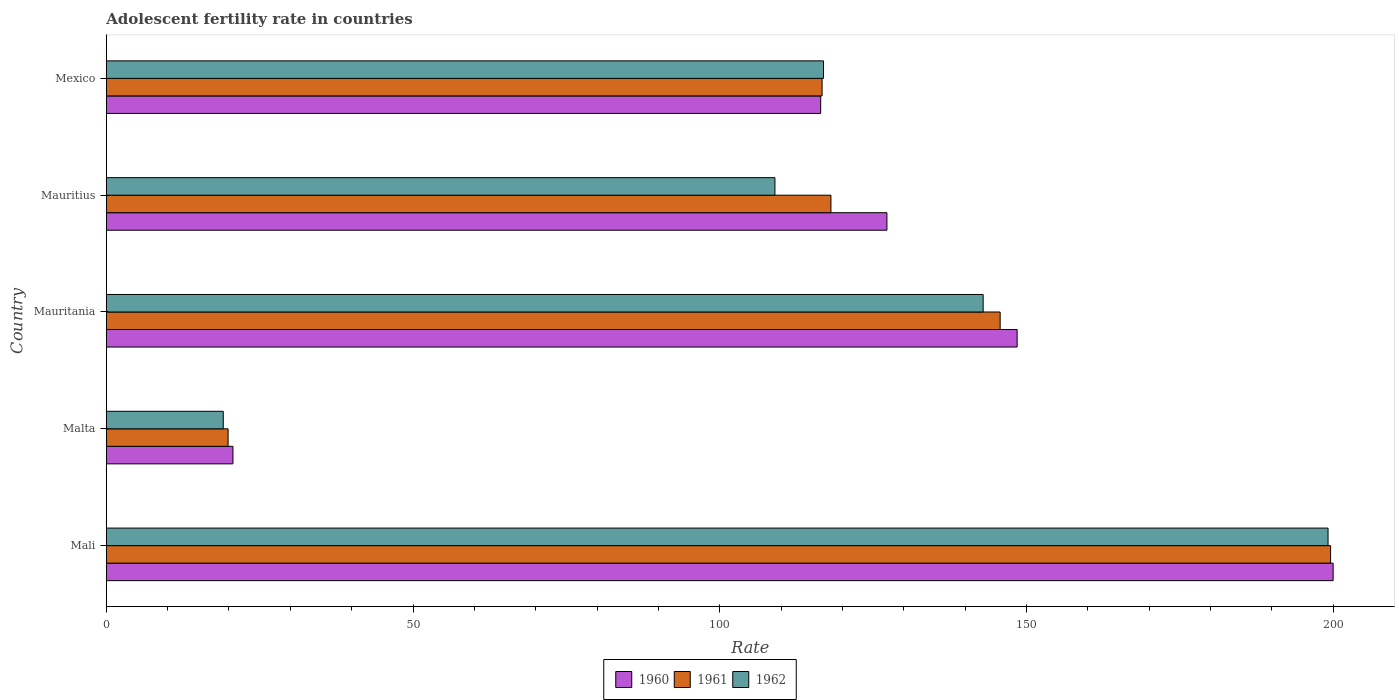How many different coloured bars are there?
Offer a very short reply. 3. How many groups of bars are there?
Offer a terse response. 5. Are the number of bars per tick equal to the number of legend labels?
Make the answer very short. Yes. How many bars are there on the 5th tick from the top?
Make the answer very short. 3. How many bars are there on the 5th tick from the bottom?
Give a very brief answer. 3. What is the label of the 2nd group of bars from the top?
Ensure brevity in your answer.  Mauritius. In how many cases, is the number of bars for a given country not equal to the number of legend labels?
Your answer should be compact. 0. What is the adolescent fertility rate in 1962 in Mali?
Your answer should be compact. 199.15. Across all countries, what is the maximum adolescent fertility rate in 1960?
Your response must be concise. 199.98. Across all countries, what is the minimum adolescent fertility rate in 1962?
Your answer should be very brief. 19.07. In which country was the adolescent fertility rate in 1960 maximum?
Your response must be concise. Mali. In which country was the adolescent fertility rate in 1962 minimum?
Offer a very short reply. Malta. What is the total adolescent fertility rate in 1961 in the graph?
Make the answer very short. 599.93. What is the difference between the adolescent fertility rate in 1961 in Mali and that in Malta?
Offer a very short reply. 179.7. What is the difference between the adolescent fertility rate in 1962 in Mauritius and the adolescent fertility rate in 1960 in Malta?
Provide a succinct answer. 88.34. What is the average adolescent fertility rate in 1961 per country?
Make the answer very short. 119.99. What is the difference between the adolescent fertility rate in 1961 and adolescent fertility rate in 1962 in Malta?
Keep it short and to the point. 0.79. In how many countries, is the adolescent fertility rate in 1961 greater than 100 ?
Make the answer very short. 4. What is the ratio of the adolescent fertility rate in 1960 in Malta to that in Mexico?
Keep it short and to the point. 0.18. Is the adolescent fertility rate in 1960 in Mauritania less than that in Mexico?
Your response must be concise. No. Is the difference between the adolescent fertility rate in 1961 in Mali and Malta greater than the difference between the adolescent fertility rate in 1962 in Mali and Malta?
Your answer should be compact. No. What is the difference between the highest and the second highest adolescent fertility rate in 1962?
Make the answer very short. 56.22. What is the difference between the highest and the lowest adolescent fertility rate in 1962?
Your answer should be very brief. 180.07. In how many countries, is the adolescent fertility rate in 1960 greater than the average adolescent fertility rate in 1960 taken over all countries?
Give a very brief answer. 3. Is it the case that in every country, the sum of the adolescent fertility rate in 1962 and adolescent fertility rate in 1961 is greater than the adolescent fertility rate in 1960?
Provide a short and direct response. Yes. Are all the bars in the graph horizontal?
Your answer should be very brief. Yes. What is the difference between two consecutive major ticks on the X-axis?
Give a very brief answer. 50. Are the values on the major ticks of X-axis written in scientific E-notation?
Keep it short and to the point. No. How are the legend labels stacked?
Your answer should be compact. Horizontal. What is the title of the graph?
Offer a terse response. Adolescent fertility rate in countries. Does "2004" appear as one of the legend labels in the graph?
Offer a terse response. No. What is the label or title of the X-axis?
Offer a terse response. Rate. What is the label or title of the Y-axis?
Your answer should be very brief. Country. What is the Rate in 1960 in Mali?
Your response must be concise. 199.98. What is the Rate of 1961 in Mali?
Provide a succinct answer. 199.56. What is the Rate in 1962 in Mali?
Your response must be concise. 199.15. What is the Rate of 1960 in Malta?
Offer a terse response. 20.65. What is the Rate of 1961 in Malta?
Give a very brief answer. 19.86. What is the Rate of 1962 in Malta?
Keep it short and to the point. 19.07. What is the Rate of 1960 in Mauritania?
Ensure brevity in your answer.  148.47. What is the Rate in 1961 in Mauritania?
Your answer should be compact. 145.7. What is the Rate of 1962 in Mauritania?
Provide a short and direct response. 142.93. What is the Rate in 1960 in Mauritius?
Provide a short and direct response. 127.25. What is the Rate in 1961 in Mauritius?
Ensure brevity in your answer.  118.12. What is the Rate of 1962 in Mauritius?
Provide a succinct answer. 108.99. What is the Rate in 1960 in Mexico?
Provide a short and direct response. 116.45. What is the Rate of 1961 in Mexico?
Offer a terse response. 116.68. What is the Rate of 1962 in Mexico?
Offer a very short reply. 116.91. Across all countries, what is the maximum Rate of 1960?
Your answer should be compact. 199.98. Across all countries, what is the maximum Rate of 1961?
Offer a very short reply. 199.56. Across all countries, what is the maximum Rate in 1962?
Your response must be concise. 199.15. Across all countries, what is the minimum Rate of 1960?
Provide a short and direct response. 20.65. Across all countries, what is the minimum Rate of 1961?
Keep it short and to the point. 19.86. Across all countries, what is the minimum Rate of 1962?
Provide a short and direct response. 19.07. What is the total Rate of 1960 in the graph?
Your answer should be very brief. 612.8. What is the total Rate of 1961 in the graph?
Keep it short and to the point. 599.93. What is the total Rate in 1962 in the graph?
Make the answer very short. 587.06. What is the difference between the Rate in 1960 in Mali and that in Malta?
Provide a short and direct response. 179.33. What is the difference between the Rate of 1961 in Mali and that in Malta?
Your response must be concise. 179.7. What is the difference between the Rate in 1962 in Mali and that in Malta?
Your response must be concise. 180.07. What is the difference between the Rate in 1960 in Mali and that in Mauritania?
Your answer should be compact. 51.51. What is the difference between the Rate of 1961 in Mali and that in Mauritania?
Keep it short and to the point. 53.86. What is the difference between the Rate in 1962 in Mali and that in Mauritania?
Your answer should be compact. 56.22. What is the difference between the Rate in 1960 in Mali and that in Mauritius?
Provide a short and direct response. 72.73. What is the difference between the Rate of 1961 in Mali and that in Mauritius?
Make the answer very short. 81.44. What is the difference between the Rate of 1962 in Mali and that in Mauritius?
Your answer should be very brief. 90.15. What is the difference between the Rate in 1960 in Mali and that in Mexico?
Provide a short and direct response. 83.53. What is the difference between the Rate of 1961 in Mali and that in Mexico?
Provide a succinct answer. 82.88. What is the difference between the Rate in 1962 in Mali and that in Mexico?
Offer a very short reply. 82.24. What is the difference between the Rate of 1960 in Malta and that in Mauritania?
Keep it short and to the point. -127.82. What is the difference between the Rate of 1961 in Malta and that in Mauritania?
Keep it short and to the point. -125.84. What is the difference between the Rate of 1962 in Malta and that in Mauritania?
Make the answer very short. -123.86. What is the difference between the Rate in 1960 in Malta and that in Mauritius?
Make the answer very short. -106.6. What is the difference between the Rate in 1961 in Malta and that in Mauritius?
Offer a very short reply. -98.26. What is the difference between the Rate in 1962 in Malta and that in Mauritius?
Offer a terse response. -89.92. What is the difference between the Rate of 1960 in Malta and that in Mexico?
Your answer should be compact. -95.8. What is the difference between the Rate of 1961 in Malta and that in Mexico?
Give a very brief answer. -96.82. What is the difference between the Rate in 1962 in Malta and that in Mexico?
Give a very brief answer. -97.84. What is the difference between the Rate in 1960 in Mauritania and that in Mauritius?
Your answer should be compact. 21.23. What is the difference between the Rate in 1961 in Mauritania and that in Mauritius?
Give a very brief answer. 27.58. What is the difference between the Rate of 1962 in Mauritania and that in Mauritius?
Make the answer very short. 33.94. What is the difference between the Rate in 1960 in Mauritania and that in Mexico?
Your answer should be very brief. 32.02. What is the difference between the Rate of 1961 in Mauritania and that in Mexico?
Provide a succinct answer. 29.02. What is the difference between the Rate of 1962 in Mauritania and that in Mexico?
Offer a very short reply. 26.02. What is the difference between the Rate in 1960 in Mauritius and that in Mexico?
Offer a terse response. 10.8. What is the difference between the Rate of 1961 in Mauritius and that in Mexico?
Your answer should be very brief. 1.44. What is the difference between the Rate of 1962 in Mauritius and that in Mexico?
Your answer should be very brief. -7.92. What is the difference between the Rate of 1960 in Mali and the Rate of 1961 in Malta?
Your answer should be compact. 180.12. What is the difference between the Rate in 1960 in Mali and the Rate in 1962 in Malta?
Offer a terse response. 180.91. What is the difference between the Rate of 1961 in Mali and the Rate of 1962 in Malta?
Ensure brevity in your answer.  180.49. What is the difference between the Rate in 1960 in Mali and the Rate in 1961 in Mauritania?
Give a very brief answer. 54.28. What is the difference between the Rate of 1960 in Mali and the Rate of 1962 in Mauritania?
Provide a succinct answer. 57.05. What is the difference between the Rate of 1961 in Mali and the Rate of 1962 in Mauritania?
Offer a terse response. 56.63. What is the difference between the Rate of 1960 in Mali and the Rate of 1961 in Mauritius?
Offer a terse response. 81.86. What is the difference between the Rate of 1960 in Mali and the Rate of 1962 in Mauritius?
Provide a succinct answer. 90.99. What is the difference between the Rate in 1961 in Mali and the Rate in 1962 in Mauritius?
Ensure brevity in your answer.  90.57. What is the difference between the Rate of 1960 in Mali and the Rate of 1961 in Mexico?
Your answer should be compact. 83.3. What is the difference between the Rate of 1960 in Mali and the Rate of 1962 in Mexico?
Make the answer very short. 83.07. What is the difference between the Rate of 1961 in Mali and the Rate of 1962 in Mexico?
Offer a very short reply. 82.65. What is the difference between the Rate in 1960 in Malta and the Rate in 1961 in Mauritania?
Ensure brevity in your answer.  -125.05. What is the difference between the Rate of 1960 in Malta and the Rate of 1962 in Mauritania?
Ensure brevity in your answer.  -122.28. What is the difference between the Rate in 1961 in Malta and the Rate in 1962 in Mauritania?
Keep it short and to the point. -123.07. What is the difference between the Rate in 1960 in Malta and the Rate in 1961 in Mauritius?
Ensure brevity in your answer.  -97.47. What is the difference between the Rate in 1960 in Malta and the Rate in 1962 in Mauritius?
Provide a succinct answer. -88.34. What is the difference between the Rate of 1961 in Malta and the Rate of 1962 in Mauritius?
Offer a terse response. -89.13. What is the difference between the Rate in 1960 in Malta and the Rate in 1961 in Mexico?
Offer a very short reply. -96.03. What is the difference between the Rate in 1960 in Malta and the Rate in 1962 in Mexico?
Offer a very short reply. -96.26. What is the difference between the Rate of 1961 in Malta and the Rate of 1962 in Mexico?
Keep it short and to the point. -97.05. What is the difference between the Rate in 1960 in Mauritania and the Rate in 1961 in Mauritius?
Offer a very short reply. 30.35. What is the difference between the Rate of 1960 in Mauritania and the Rate of 1962 in Mauritius?
Your answer should be very brief. 39.48. What is the difference between the Rate in 1961 in Mauritania and the Rate in 1962 in Mauritius?
Provide a succinct answer. 36.71. What is the difference between the Rate in 1960 in Mauritania and the Rate in 1961 in Mexico?
Provide a succinct answer. 31.79. What is the difference between the Rate of 1960 in Mauritania and the Rate of 1962 in Mexico?
Make the answer very short. 31.56. What is the difference between the Rate in 1961 in Mauritania and the Rate in 1962 in Mexico?
Your answer should be compact. 28.79. What is the difference between the Rate of 1960 in Mauritius and the Rate of 1961 in Mexico?
Give a very brief answer. 10.57. What is the difference between the Rate in 1960 in Mauritius and the Rate in 1962 in Mexico?
Your answer should be very brief. 10.34. What is the difference between the Rate in 1961 in Mauritius and the Rate in 1962 in Mexico?
Your answer should be very brief. 1.21. What is the average Rate in 1960 per country?
Provide a short and direct response. 122.56. What is the average Rate in 1961 per country?
Keep it short and to the point. 119.99. What is the average Rate in 1962 per country?
Ensure brevity in your answer.  117.41. What is the difference between the Rate in 1960 and Rate in 1961 in Mali?
Ensure brevity in your answer.  0.42. What is the difference between the Rate in 1960 and Rate in 1962 in Mali?
Your answer should be compact. 0.83. What is the difference between the Rate in 1961 and Rate in 1962 in Mali?
Provide a succinct answer. 0.42. What is the difference between the Rate in 1960 and Rate in 1961 in Malta?
Give a very brief answer. 0.79. What is the difference between the Rate in 1960 and Rate in 1962 in Malta?
Make the answer very short. 1.58. What is the difference between the Rate of 1961 and Rate of 1962 in Malta?
Keep it short and to the point. 0.79. What is the difference between the Rate of 1960 and Rate of 1961 in Mauritania?
Your answer should be very brief. 2.77. What is the difference between the Rate in 1960 and Rate in 1962 in Mauritania?
Keep it short and to the point. 5.54. What is the difference between the Rate of 1961 and Rate of 1962 in Mauritania?
Offer a terse response. 2.77. What is the difference between the Rate in 1960 and Rate in 1961 in Mauritius?
Ensure brevity in your answer.  9.13. What is the difference between the Rate in 1960 and Rate in 1962 in Mauritius?
Offer a terse response. 18.25. What is the difference between the Rate of 1961 and Rate of 1962 in Mauritius?
Make the answer very short. 9.13. What is the difference between the Rate in 1960 and Rate in 1961 in Mexico?
Offer a very short reply. -0.23. What is the difference between the Rate of 1960 and Rate of 1962 in Mexico?
Keep it short and to the point. -0.46. What is the difference between the Rate in 1961 and Rate in 1962 in Mexico?
Make the answer very short. -0.23. What is the ratio of the Rate in 1960 in Mali to that in Malta?
Ensure brevity in your answer.  9.68. What is the ratio of the Rate of 1961 in Mali to that in Malta?
Offer a terse response. 10.05. What is the ratio of the Rate in 1962 in Mali to that in Malta?
Ensure brevity in your answer.  10.44. What is the ratio of the Rate in 1960 in Mali to that in Mauritania?
Offer a very short reply. 1.35. What is the ratio of the Rate in 1961 in Mali to that in Mauritania?
Your response must be concise. 1.37. What is the ratio of the Rate of 1962 in Mali to that in Mauritania?
Your answer should be very brief. 1.39. What is the ratio of the Rate in 1960 in Mali to that in Mauritius?
Offer a very short reply. 1.57. What is the ratio of the Rate in 1961 in Mali to that in Mauritius?
Offer a terse response. 1.69. What is the ratio of the Rate in 1962 in Mali to that in Mauritius?
Give a very brief answer. 1.83. What is the ratio of the Rate in 1960 in Mali to that in Mexico?
Offer a terse response. 1.72. What is the ratio of the Rate of 1961 in Mali to that in Mexico?
Your response must be concise. 1.71. What is the ratio of the Rate of 1962 in Mali to that in Mexico?
Provide a succinct answer. 1.7. What is the ratio of the Rate in 1960 in Malta to that in Mauritania?
Your answer should be compact. 0.14. What is the ratio of the Rate of 1961 in Malta to that in Mauritania?
Keep it short and to the point. 0.14. What is the ratio of the Rate of 1962 in Malta to that in Mauritania?
Your response must be concise. 0.13. What is the ratio of the Rate in 1960 in Malta to that in Mauritius?
Provide a succinct answer. 0.16. What is the ratio of the Rate in 1961 in Malta to that in Mauritius?
Provide a succinct answer. 0.17. What is the ratio of the Rate in 1962 in Malta to that in Mauritius?
Offer a terse response. 0.17. What is the ratio of the Rate of 1960 in Malta to that in Mexico?
Provide a short and direct response. 0.18. What is the ratio of the Rate in 1961 in Malta to that in Mexico?
Your answer should be compact. 0.17. What is the ratio of the Rate in 1962 in Malta to that in Mexico?
Provide a short and direct response. 0.16. What is the ratio of the Rate in 1960 in Mauritania to that in Mauritius?
Ensure brevity in your answer.  1.17. What is the ratio of the Rate in 1961 in Mauritania to that in Mauritius?
Your response must be concise. 1.23. What is the ratio of the Rate of 1962 in Mauritania to that in Mauritius?
Your answer should be compact. 1.31. What is the ratio of the Rate in 1960 in Mauritania to that in Mexico?
Keep it short and to the point. 1.27. What is the ratio of the Rate in 1961 in Mauritania to that in Mexico?
Provide a short and direct response. 1.25. What is the ratio of the Rate in 1962 in Mauritania to that in Mexico?
Your answer should be compact. 1.22. What is the ratio of the Rate in 1960 in Mauritius to that in Mexico?
Give a very brief answer. 1.09. What is the ratio of the Rate of 1961 in Mauritius to that in Mexico?
Make the answer very short. 1.01. What is the ratio of the Rate in 1962 in Mauritius to that in Mexico?
Your response must be concise. 0.93. What is the difference between the highest and the second highest Rate of 1960?
Ensure brevity in your answer.  51.51. What is the difference between the highest and the second highest Rate of 1961?
Your response must be concise. 53.86. What is the difference between the highest and the second highest Rate of 1962?
Provide a short and direct response. 56.22. What is the difference between the highest and the lowest Rate of 1960?
Provide a succinct answer. 179.33. What is the difference between the highest and the lowest Rate in 1961?
Keep it short and to the point. 179.7. What is the difference between the highest and the lowest Rate in 1962?
Ensure brevity in your answer.  180.07. 